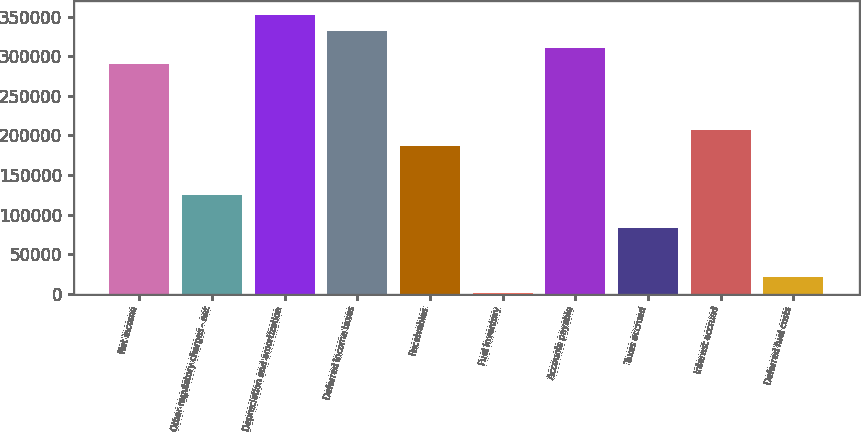Convert chart to OTSL. <chart><loc_0><loc_0><loc_500><loc_500><bar_chart><fcel>Net income<fcel>Other regulatory charges - net<fcel>Depreciation and amortization<fcel>Deferred income taxes<fcel>Receivables<fcel>Fuel inventory<fcel>Accounts payable<fcel>Taxes accrued<fcel>Interest accrued<fcel>Deferred fuel costs<nl><fcel>290135<fcel>124653<fcel>352191<fcel>331506<fcel>186709<fcel>541<fcel>310820<fcel>83282.2<fcel>207394<fcel>21226.3<nl></chart> 